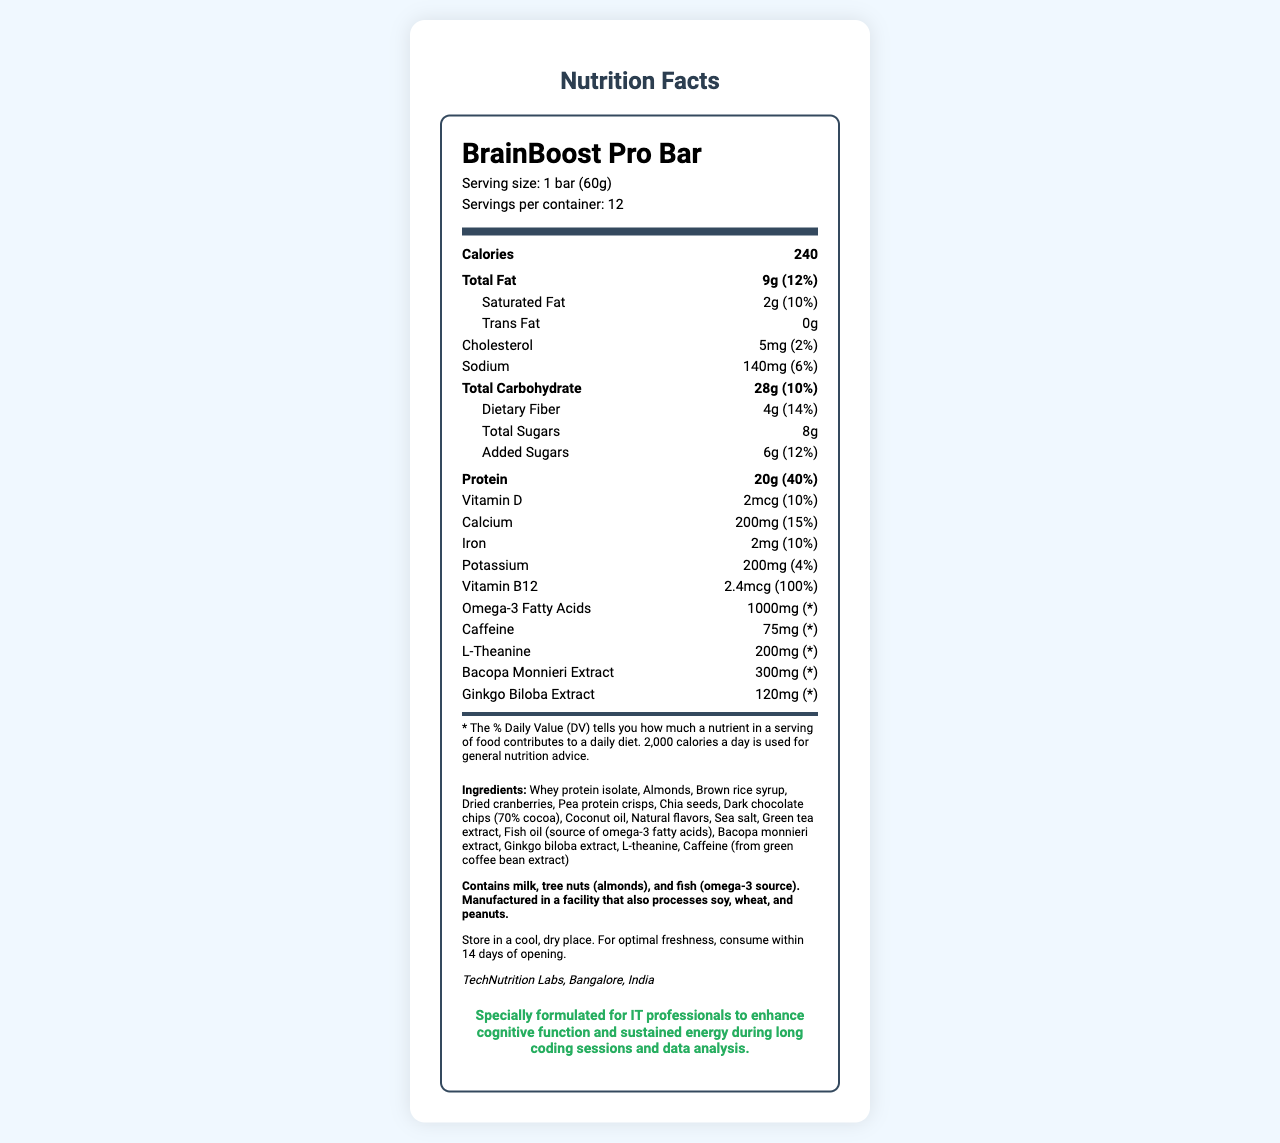what is the serving size of BrainBoost Pro Bar? The serving size is specified as "1 bar (60g)" in the document.
Answer: 1 bar (60g) how many servings are in one container? The document states that there are 12 servings per container.
Answer: 12 how many calories are in one bar? The number of calories per serving is listed as 240 in the document.
Answer: 240 what is the percentage of the daily value for total fat? The document indicates "Total Fat: 9g (12%)".
Answer: 12% how much protein does one bar contain? The protein content per serving is listed as "20g (40%)".
Answer: 20g which ingredient contains caffeine? A. Whey protein isolate B. Green tea extract C. Almonds D. Sea salt The document lists caffeine as being derived from "green coffee bean extract," which is part of the green tea extract item.
Answer: B what is the daily value percentage for iron? A. 2% B. 4% C. 10% D. 15% The iron content has a daily value of 10%, as shown in the document.
Answer: C how much vitamin B12 is in one serving? The vitamin B12 content is listed as "2.4mcg (100%)" in the document.
Answer: 2.4mcg is there any trans fat in the BrainBoost Pro Bar? The document specifies "Trans Fat: 0g."
Answer: No how should the BrainBoost Pro Bar be stored? The document clearly outlines the storage instructions.
Answer: Store in a cool, dry place. For optimal freshness, consume within 14 days of opening. how many milligrams of sodium does one bar contain? The amount of sodium per serving is listed as 140mg.
Answer: 140mg does the BrainBoost Pro Bar contain any allergens? The document lists that the bar contains milk, tree nuts (almonds), and fish (omega-3 source).
Answer: Yes who is the manufacturer of the BrainBoost Pro Bar? The manufacturer is mentioned as TechNutrition Labs, Bangalore, India.
Answer: TechNutrition Labs, Bangalore, India what ingredients are specifically noted to enhance cognitive function? The document lists these ingredients as part of the special formulation for cognitive enhancement.
Answer: L-theanine, Bacopa monnieri extract, Ginkgo biloba extract, Caffeine summarize the main idea of the document. The document aims to inform consumers about the nutrient content and benefits of the BrainBoost Pro Bar, emphasizing its use for enhancing cognitive function in IT professionals.
Answer: The document provides the nutrition facts for the BrainBoost Pro Bar, detailing the serving size, calories, macronutrients, vitamins, and minerals. It also includes information on special cognitive function ingredients, allergens, storage instructions, the manufacturer, and the intended use for IT professionals. what is the daily value percentage for added sugars? The amount of added sugars per bar is 6g, which corresponds to 12% of the daily value according to the document.
Answer: 12% is there any information about the cost of the BrainBoost Pro Bar in the document? The document does not mention anything about the cost of the BrainBoost Pro Bar.
Answer: Not enough information 